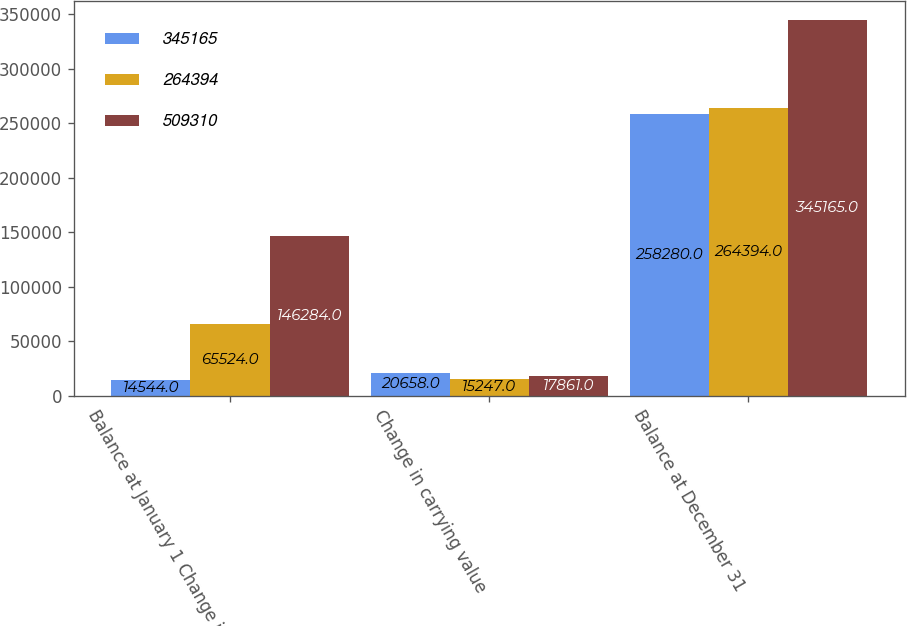Convert chart. <chart><loc_0><loc_0><loc_500><loc_500><stacked_bar_chart><ecel><fcel>Balance at January 1 Change in<fcel>Change in carrying value<fcel>Balance at December 31<nl><fcel>345165<fcel>14544<fcel>20658<fcel>258280<nl><fcel>264394<fcel>65524<fcel>15247<fcel>264394<nl><fcel>509310<fcel>146284<fcel>17861<fcel>345165<nl></chart> 